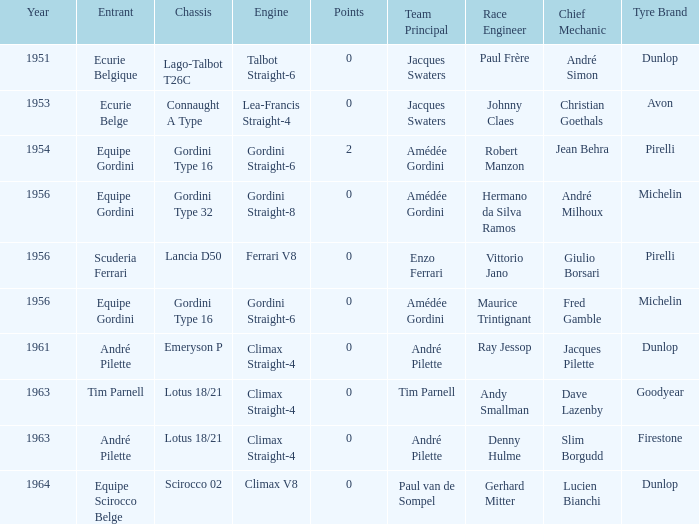Who used Gordini Straight-6 in 1956? Equipe Gordini. 